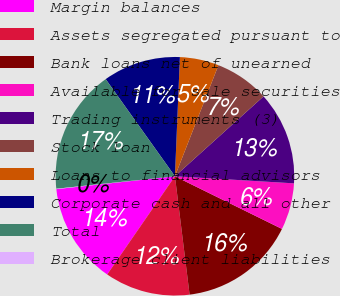<chart> <loc_0><loc_0><loc_500><loc_500><pie_chart><fcel>Margin balances<fcel>Assets segregated pursuant to<fcel>Bank loans net of unearned<fcel>Available for sale securities<fcel>Trading instruments (3)<fcel>Stock loan<fcel>Loans to financial advisors<fcel>Corporate cash and all other<fcel>Total<fcel>Brokerage client liabilities<nl><fcel>13.67%<fcel>11.57%<fcel>15.76%<fcel>6.33%<fcel>12.62%<fcel>7.38%<fcel>5.28%<fcel>10.52%<fcel>16.81%<fcel>0.05%<nl></chart> 